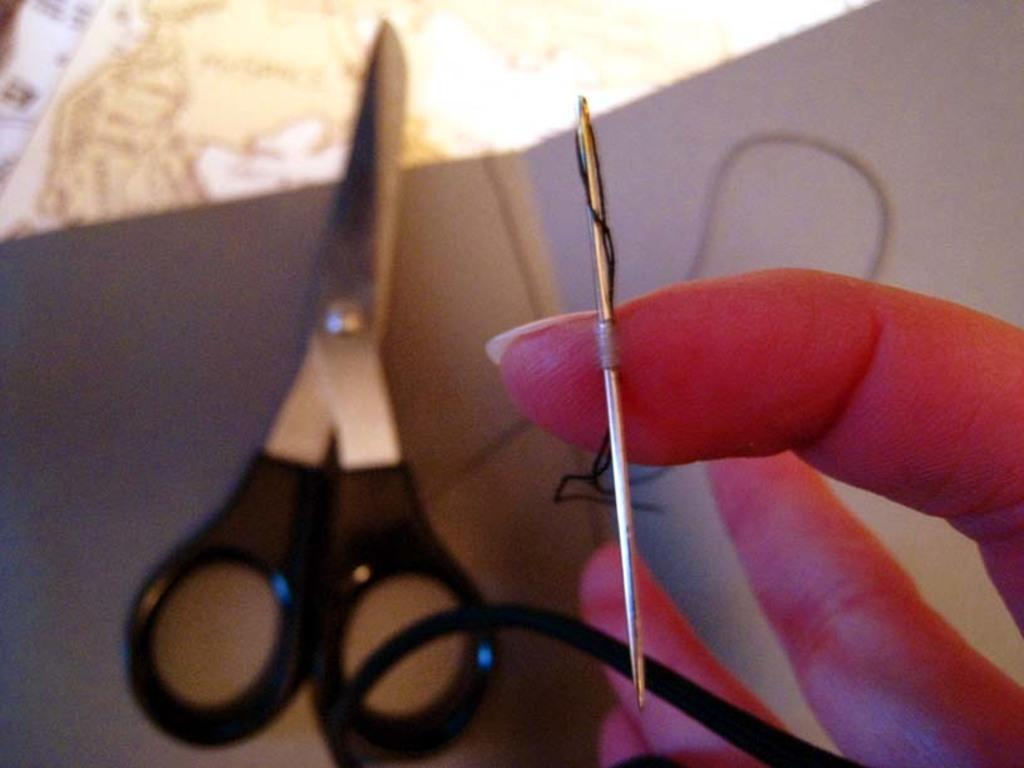What is the main subject of the image? There is a person in the image. What is the person holding in the image? The person is holding a needle. What other object can be seen in the image? There is a scissor in the image. Where is the scissor placed in relation to the person? The scissor is kept in front of the person. Can you see a stream flowing near the person in the image? There is no stream visible in the image. How many legs does the person have in the image? The image only shows the person from the waist up, so it is impossible to determine the number of legs. 